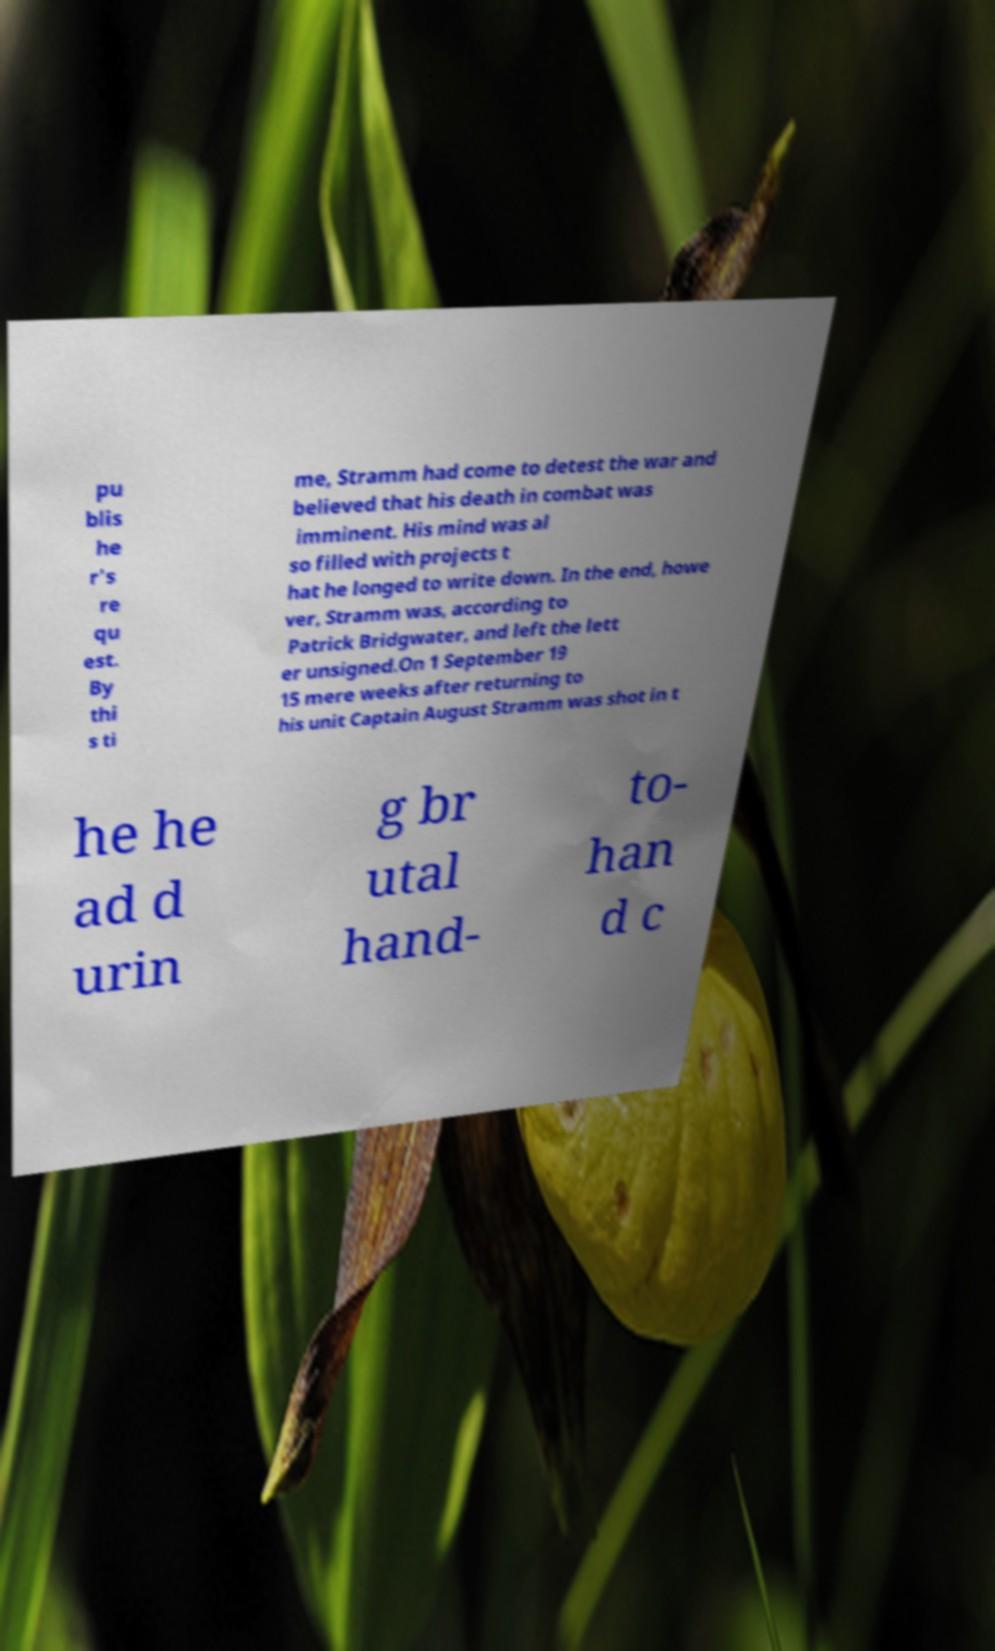Can you read and provide the text displayed in the image?This photo seems to have some interesting text. Can you extract and type it out for me? pu blis he r's re qu est. By thi s ti me, Stramm had come to detest the war and believed that his death in combat was imminent. His mind was al so filled with projects t hat he longed to write down. In the end, howe ver, Stramm was, according to Patrick Bridgwater, and left the lett er unsigned.On 1 September 19 15 mere weeks after returning to his unit Captain August Stramm was shot in t he he ad d urin g br utal hand- to- han d c 